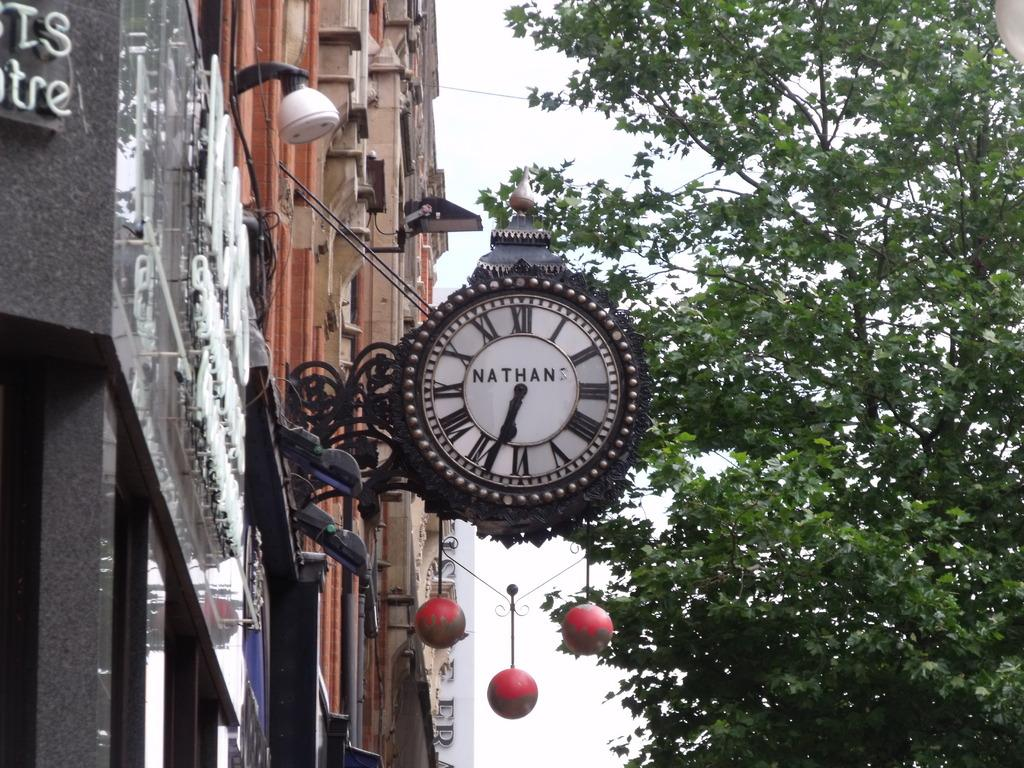<image>
Give a short and clear explanation of the subsequent image. An olden style clock with Nathan on the face hangs from the side of the building. 